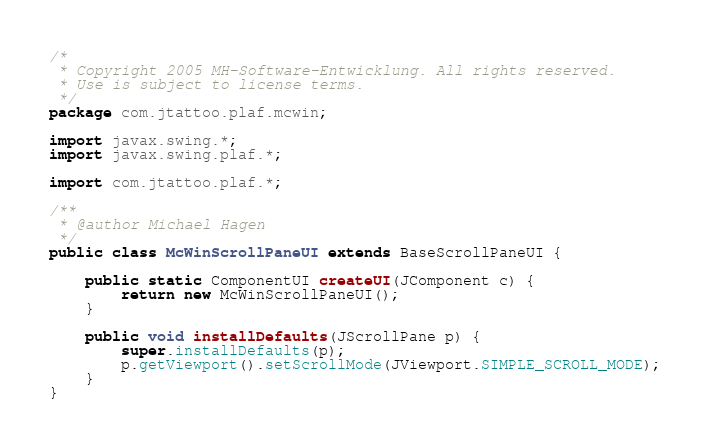<code> <loc_0><loc_0><loc_500><loc_500><_Java_>/*
 * Copyright 2005 MH-Software-Entwicklung. All rights reserved.
 * Use is subject to license terms.
 */
package com.jtattoo.plaf.mcwin;

import javax.swing.*;
import javax.swing.plaf.*;

import com.jtattoo.plaf.*;

/**
 * @author Michael Hagen
 */
public class McWinScrollPaneUI extends BaseScrollPaneUI {

    public static ComponentUI createUI(JComponent c) {
        return new McWinScrollPaneUI();
    }

    public void installDefaults(JScrollPane p) {
        super.installDefaults(p);
        p.getViewport().setScrollMode(JViewport.SIMPLE_SCROLL_MODE);
    }
}
</code> 